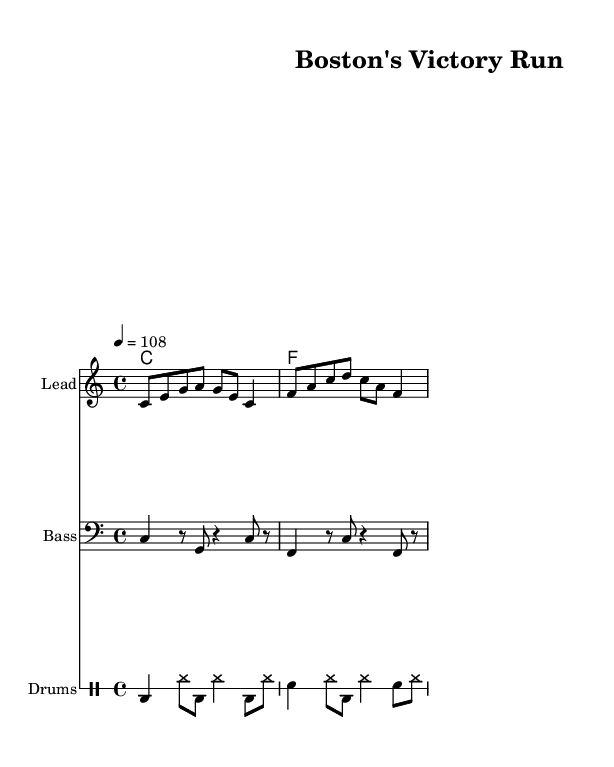What is the key signature of this music? The key signature indicated in the music is C major, which has no sharps or flats in its key signature.
Answer: C major What is the time signature of this music? The time signature at the beginning of the music is 4/4, meaning there are four beats in each measure, and the quarter note gets one beat.
Answer: 4/4 What is the tempo marking of this music? The tempo marking states "4 = 108", which indicates that the quarter note should be played at a speed of 108 beats per minute.
Answer: 108 Which instrument plays the melody? The lead instrument is designated as "Lead" in the sheet music, where the melody line is written.
Answer: Lead How many measures are in the melody? The melody consists of two measures in total, as shown in the written music. Each line contains one measure, adding up to two.
Answer: 2 What type of rhythmic pattern is primarily used in the drums part? The drums part primarily features a combination of bass drum (bd) and snare drum (sn) patterns with hi-hats (hh) creating a consistent rhythmic feel typical in reggae music.
Answer: Reggae rhythm What lyrical theme is expressed in the song? The lyrics reflect an athletic theme, mentioning "running down the field," which indicates a focus on sports and physical performance, common in upbeat reggae music.
Answer: Sports 